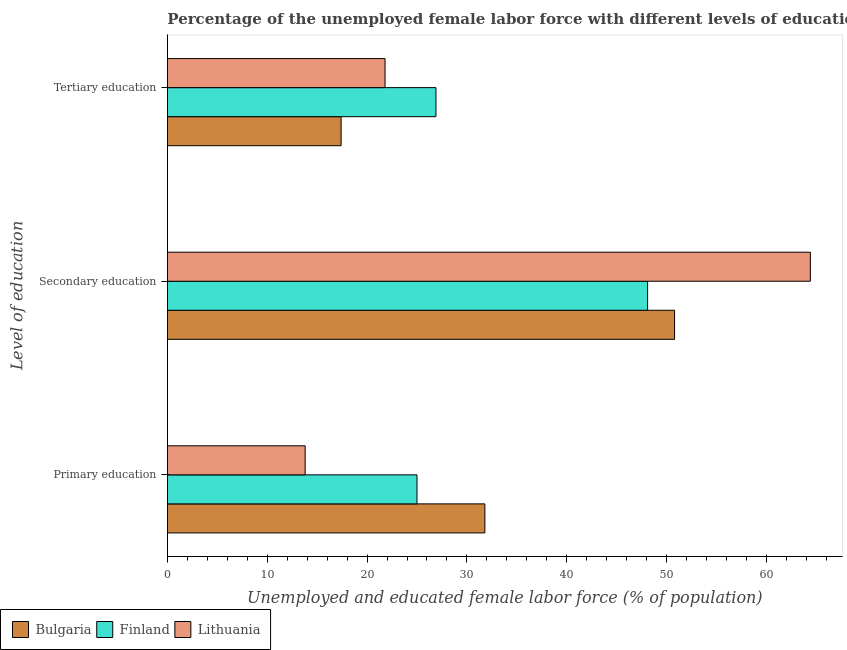How many different coloured bars are there?
Offer a terse response. 3. How many groups of bars are there?
Your response must be concise. 3. Are the number of bars per tick equal to the number of legend labels?
Offer a terse response. Yes. Are the number of bars on each tick of the Y-axis equal?
Your answer should be very brief. Yes. How many bars are there on the 2nd tick from the bottom?
Make the answer very short. 3. What is the label of the 1st group of bars from the top?
Keep it short and to the point. Tertiary education. What is the percentage of female labor force who received tertiary education in Lithuania?
Offer a very short reply. 21.8. Across all countries, what is the maximum percentage of female labor force who received secondary education?
Provide a short and direct response. 64.4. Across all countries, what is the minimum percentage of female labor force who received primary education?
Provide a succinct answer. 13.8. In which country was the percentage of female labor force who received primary education minimum?
Your answer should be very brief. Lithuania. What is the total percentage of female labor force who received tertiary education in the graph?
Offer a terse response. 66.1. What is the difference between the percentage of female labor force who received tertiary education in Bulgaria and that in Lithuania?
Keep it short and to the point. -4.4. What is the difference between the percentage of female labor force who received tertiary education in Finland and the percentage of female labor force who received secondary education in Lithuania?
Offer a terse response. -37.5. What is the average percentage of female labor force who received tertiary education per country?
Your response must be concise. 22.03. What is the difference between the percentage of female labor force who received tertiary education and percentage of female labor force who received secondary education in Lithuania?
Provide a succinct answer. -42.6. In how many countries, is the percentage of female labor force who received primary education greater than 64 %?
Ensure brevity in your answer.  0. What is the ratio of the percentage of female labor force who received tertiary education in Bulgaria to that in Finland?
Make the answer very short. 0.65. What is the difference between the highest and the second highest percentage of female labor force who received secondary education?
Offer a very short reply. 13.6. What is the difference between the highest and the lowest percentage of female labor force who received tertiary education?
Your response must be concise. 9.5. Is the sum of the percentage of female labor force who received tertiary education in Finland and Lithuania greater than the maximum percentage of female labor force who received secondary education across all countries?
Provide a short and direct response. No. What does the 1st bar from the top in Primary education represents?
Provide a short and direct response. Lithuania. What does the 3rd bar from the bottom in Primary education represents?
Provide a succinct answer. Lithuania. Are all the bars in the graph horizontal?
Keep it short and to the point. Yes. What is the difference between two consecutive major ticks on the X-axis?
Your answer should be compact. 10. Are the values on the major ticks of X-axis written in scientific E-notation?
Offer a very short reply. No. Does the graph contain any zero values?
Provide a succinct answer. No. How many legend labels are there?
Offer a very short reply. 3. How are the legend labels stacked?
Provide a short and direct response. Horizontal. What is the title of the graph?
Ensure brevity in your answer.  Percentage of the unemployed female labor force with different levels of education in countries. What is the label or title of the X-axis?
Your answer should be very brief. Unemployed and educated female labor force (% of population). What is the label or title of the Y-axis?
Provide a succinct answer. Level of education. What is the Unemployed and educated female labor force (% of population) in Bulgaria in Primary education?
Your response must be concise. 31.8. What is the Unemployed and educated female labor force (% of population) of Lithuania in Primary education?
Ensure brevity in your answer.  13.8. What is the Unemployed and educated female labor force (% of population) of Bulgaria in Secondary education?
Provide a succinct answer. 50.8. What is the Unemployed and educated female labor force (% of population) of Finland in Secondary education?
Your answer should be compact. 48.1. What is the Unemployed and educated female labor force (% of population) of Lithuania in Secondary education?
Offer a terse response. 64.4. What is the Unemployed and educated female labor force (% of population) of Bulgaria in Tertiary education?
Keep it short and to the point. 17.4. What is the Unemployed and educated female labor force (% of population) of Finland in Tertiary education?
Your answer should be very brief. 26.9. What is the Unemployed and educated female labor force (% of population) of Lithuania in Tertiary education?
Provide a succinct answer. 21.8. Across all Level of education, what is the maximum Unemployed and educated female labor force (% of population) in Bulgaria?
Your response must be concise. 50.8. Across all Level of education, what is the maximum Unemployed and educated female labor force (% of population) of Finland?
Keep it short and to the point. 48.1. Across all Level of education, what is the maximum Unemployed and educated female labor force (% of population) of Lithuania?
Offer a terse response. 64.4. Across all Level of education, what is the minimum Unemployed and educated female labor force (% of population) in Bulgaria?
Your answer should be compact. 17.4. Across all Level of education, what is the minimum Unemployed and educated female labor force (% of population) in Finland?
Your answer should be very brief. 25. Across all Level of education, what is the minimum Unemployed and educated female labor force (% of population) of Lithuania?
Ensure brevity in your answer.  13.8. What is the total Unemployed and educated female labor force (% of population) in Bulgaria in the graph?
Offer a very short reply. 100. What is the total Unemployed and educated female labor force (% of population) in Finland in the graph?
Give a very brief answer. 100. What is the difference between the Unemployed and educated female labor force (% of population) in Bulgaria in Primary education and that in Secondary education?
Provide a succinct answer. -19. What is the difference between the Unemployed and educated female labor force (% of population) in Finland in Primary education and that in Secondary education?
Your response must be concise. -23.1. What is the difference between the Unemployed and educated female labor force (% of population) in Lithuania in Primary education and that in Secondary education?
Keep it short and to the point. -50.6. What is the difference between the Unemployed and educated female labor force (% of population) in Finland in Primary education and that in Tertiary education?
Your answer should be very brief. -1.9. What is the difference between the Unemployed and educated female labor force (% of population) in Lithuania in Primary education and that in Tertiary education?
Your answer should be very brief. -8. What is the difference between the Unemployed and educated female labor force (% of population) in Bulgaria in Secondary education and that in Tertiary education?
Provide a succinct answer. 33.4. What is the difference between the Unemployed and educated female labor force (% of population) in Finland in Secondary education and that in Tertiary education?
Ensure brevity in your answer.  21.2. What is the difference between the Unemployed and educated female labor force (% of population) in Lithuania in Secondary education and that in Tertiary education?
Ensure brevity in your answer.  42.6. What is the difference between the Unemployed and educated female labor force (% of population) of Bulgaria in Primary education and the Unemployed and educated female labor force (% of population) of Finland in Secondary education?
Make the answer very short. -16.3. What is the difference between the Unemployed and educated female labor force (% of population) in Bulgaria in Primary education and the Unemployed and educated female labor force (% of population) in Lithuania in Secondary education?
Your answer should be very brief. -32.6. What is the difference between the Unemployed and educated female labor force (% of population) in Finland in Primary education and the Unemployed and educated female labor force (% of population) in Lithuania in Secondary education?
Provide a succinct answer. -39.4. What is the difference between the Unemployed and educated female labor force (% of population) in Finland in Primary education and the Unemployed and educated female labor force (% of population) in Lithuania in Tertiary education?
Provide a succinct answer. 3.2. What is the difference between the Unemployed and educated female labor force (% of population) of Bulgaria in Secondary education and the Unemployed and educated female labor force (% of population) of Finland in Tertiary education?
Give a very brief answer. 23.9. What is the difference between the Unemployed and educated female labor force (% of population) of Finland in Secondary education and the Unemployed and educated female labor force (% of population) of Lithuania in Tertiary education?
Keep it short and to the point. 26.3. What is the average Unemployed and educated female labor force (% of population) of Bulgaria per Level of education?
Ensure brevity in your answer.  33.33. What is the average Unemployed and educated female labor force (% of population) of Finland per Level of education?
Ensure brevity in your answer.  33.33. What is the average Unemployed and educated female labor force (% of population) of Lithuania per Level of education?
Provide a succinct answer. 33.33. What is the difference between the Unemployed and educated female labor force (% of population) in Bulgaria and Unemployed and educated female labor force (% of population) in Finland in Primary education?
Your answer should be compact. 6.8. What is the difference between the Unemployed and educated female labor force (% of population) of Finland and Unemployed and educated female labor force (% of population) of Lithuania in Primary education?
Offer a terse response. 11.2. What is the difference between the Unemployed and educated female labor force (% of population) in Finland and Unemployed and educated female labor force (% of population) in Lithuania in Secondary education?
Keep it short and to the point. -16.3. What is the difference between the Unemployed and educated female labor force (% of population) in Bulgaria and Unemployed and educated female labor force (% of population) in Lithuania in Tertiary education?
Make the answer very short. -4.4. What is the difference between the Unemployed and educated female labor force (% of population) of Finland and Unemployed and educated female labor force (% of population) of Lithuania in Tertiary education?
Keep it short and to the point. 5.1. What is the ratio of the Unemployed and educated female labor force (% of population) of Bulgaria in Primary education to that in Secondary education?
Provide a succinct answer. 0.63. What is the ratio of the Unemployed and educated female labor force (% of population) of Finland in Primary education to that in Secondary education?
Keep it short and to the point. 0.52. What is the ratio of the Unemployed and educated female labor force (% of population) of Lithuania in Primary education to that in Secondary education?
Provide a succinct answer. 0.21. What is the ratio of the Unemployed and educated female labor force (% of population) in Bulgaria in Primary education to that in Tertiary education?
Your response must be concise. 1.83. What is the ratio of the Unemployed and educated female labor force (% of population) in Finland in Primary education to that in Tertiary education?
Provide a short and direct response. 0.93. What is the ratio of the Unemployed and educated female labor force (% of population) in Lithuania in Primary education to that in Tertiary education?
Your response must be concise. 0.63. What is the ratio of the Unemployed and educated female labor force (% of population) in Bulgaria in Secondary education to that in Tertiary education?
Offer a terse response. 2.92. What is the ratio of the Unemployed and educated female labor force (% of population) of Finland in Secondary education to that in Tertiary education?
Ensure brevity in your answer.  1.79. What is the ratio of the Unemployed and educated female labor force (% of population) of Lithuania in Secondary education to that in Tertiary education?
Provide a succinct answer. 2.95. What is the difference between the highest and the second highest Unemployed and educated female labor force (% of population) of Finland?
Keep it short and to the point. 21.2. What is the difference between the highest and the second highest Unemployed and educated female labor force (% of population) in Lithuania?
Offer a terse response. 42.6. What is the difference between the highest and the lowest Unemployed and educated female labor force (% of population) in Bulgaria?
Offer a terse response. 33.4. What is the difference between the highest and the lowest Unemployed and educated female labor force (% of population) of Finland?
Make the answer very short. 23.1. What is the difference between the highest and the lowest Unemployed and educated female labor force (% of population) in Lithuania?
Ensure brevity in your answer.  50.6. 